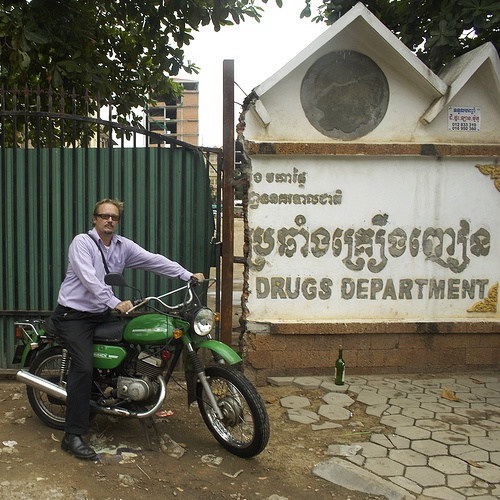Describe the objects in this image and their specific colors. I can see motorcycle in black, gray, and darkgreen tones, people in black, darkgray, gray, and lavender tones, and bottle in black, olive, gray, and darkgreen tones in this image. 